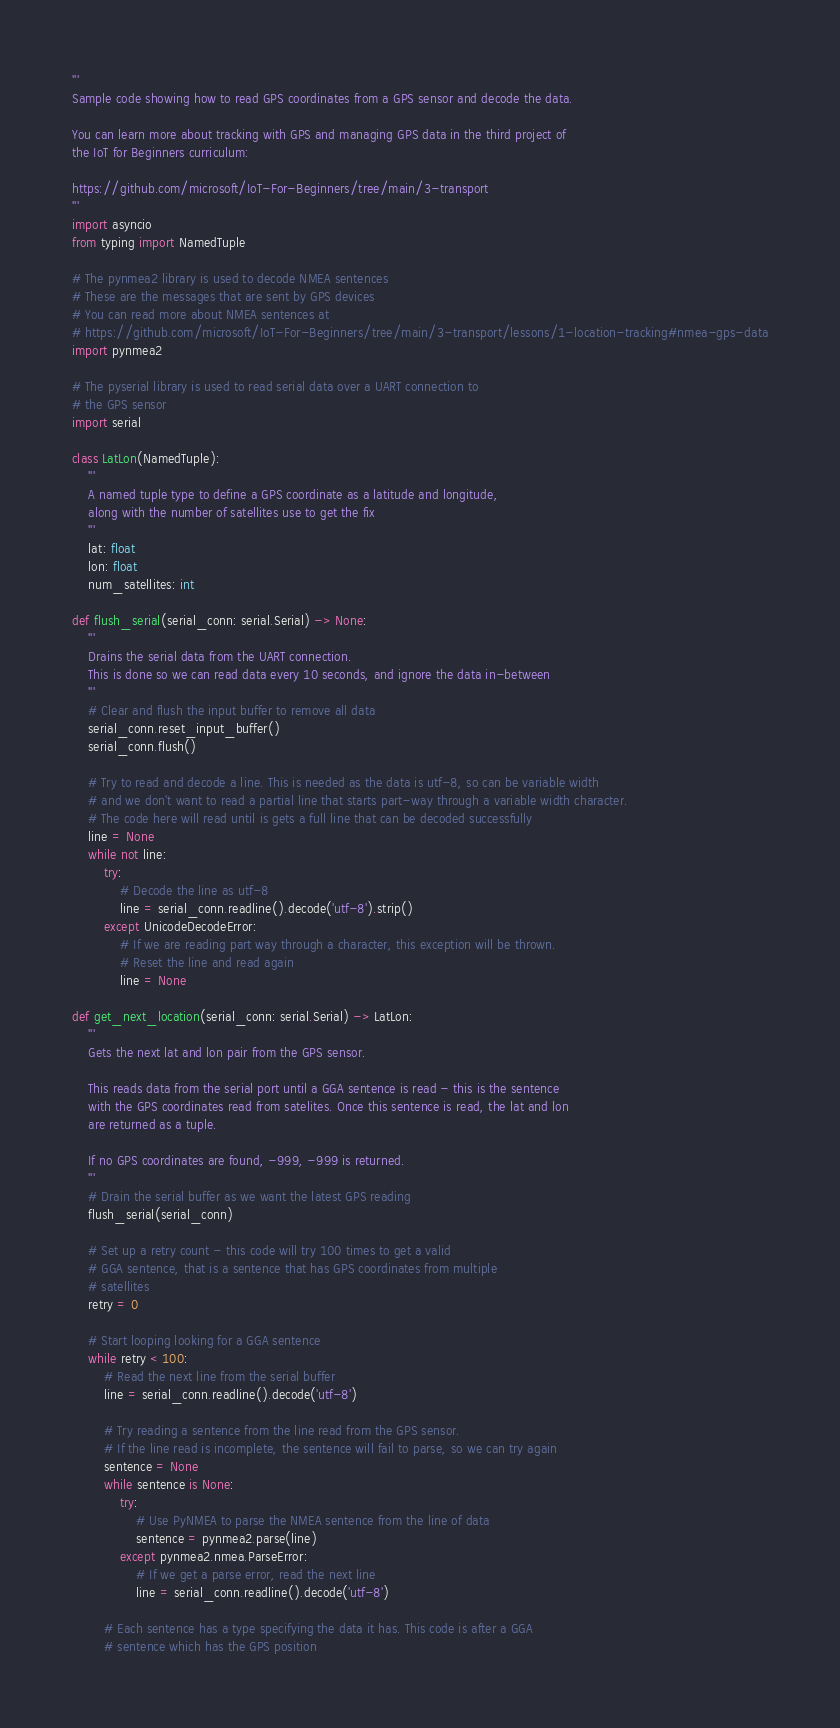<code> <loc_0><loc_0><loc_500><loc_500><_Python_>'''
Sample code showing how to read GPS coordinates from a GPS sensor and decode the data.

You can learn more about tracking with GPS and managing GPS data in the third project of
the IoT for Beginners curriculum:

https://github.com/microsoft/IoT-For-Beginners/tree/main/3-transport
'''
import asyncio
from typing import NamedTuple

# The pynmea2 library is used to decode NMEA sentences
# These are the messages that are sent by GPS devices
# You can read more about NMEA sentences at
# https://github.com/microsoft/IoT-For-Beginners/tree/main/3-transport/lessons/1-location-tracking#nmea-gps-data
import pynmea2

# The pyserial library is used to read serial data over a UART connection to
# the GPS sensor
import serial

class LatLon(NamedTuple):
    '''
    A named tuple type to define a GPS coordinate as a latitude and longitude,
    along with the number of satellites use to get the fix
    '''
    lat: float
    lon: float
    num_satellites: int

def flush_serial(serial_conn: serial.Serial) -> None:
    '''
    Drains the serial data from the UART connection.
    This is done so we can read data every 10 seconds, and ignore the data in-between
    '''
    # Clear and flush the input buffer to remove all data
    serial_conn.reset_input_buffer()
    serial_conn.flush()

    # Try to read and decode a line. This is needed as the data is utf-8, so can be variable width
    # and we don't want to read a partial line that starts part-way through a variable width character.
    # The code here will read until is gets a full line that can be decoded successfully
    line = None
    while not line:
        try:
            # Decode the line as utf-8
            line = serial_conn.readline().decode('utf-8').strip()
        except UnicodeDecodeError:
            # If we are reading part way through a character, this exception will be thrown.
            # Reset the line and read again
            line = None

def get_next_location(serial_conn: serial.Serial) -> LatLon:
    '''
    Gets the next lat and lon pair from the GPS sensor.

    This reads data from the serial port until a GGA sentence is read - this is the sentence
    with the GPS coordinates read from satelites. Once this sentence is read, the lat and lon
    are returned as a tuple.

    If no GPS coordinates are found, -999, -999 is returned.
    '''
    # Drain the serial buffer as we want the latest GPS reading
    flush_serial(serial_conn)

    # Set up a retry count - this code will try 100 times to get a valid
    # GGA sentence, that is a sentence that has GPS coordinates from multiple
    # satellites
    retry = 0

    # Start looping looking for a GGA sentence
    while retry < 100:
        # Read the next line from the serial buffer
        line = serial_conn.readline().decode('utf-8')

        # Try reading a sentence from the line read from the GPS sensor.
        # If the line read is incomplete, the sentence will fail to parse, so we can try again
        sentence = None
        while sentence is None:
            try:
                # Use PyNMEA to parse the NMEA sentence from the line of data
                sentence = pynmea2.parse(line)
            except pynmea2.nmea.ParseError:
                # If we get a parse error, read the next line
                line = serial_conn.readline().decode('utf-8')

        # Each sentence has a type specifying the data it has. This code is after a GGA
        # sentence which has the GPS position</code> 